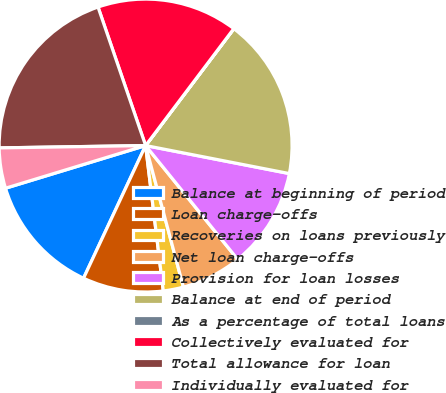Convert chart to OTSL. <chart><loc_0><loc_0><loc_500><loc_500><pie_chart><fcel>Balance at beginning of period<fcel>Loan charge-offs<fcel>Recoveries on loans previously<fcel>Net loan charge-offs<fcel>Provision for loan losses<fcel>Balance at end of period<fcel>As a percentage of total loans<fcel>Collectively evaluated for<fcel>Total allowance for loan<fcel>Individually evaluated for<nl><fcel>13.33%<fcel>8.89%<fcel>2.23%<fcel>6.67%<fcel>11.11%<fcel>17.77%<fcel>0.01%<fcel>15.55%<fcel>19.99%<fcel>4.45%<nl></chart> 